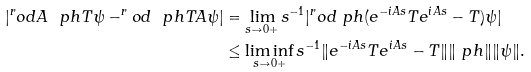Convert formula to latex. <formula><loc_0><loc_0><loc_500><loc_500>| ^ { r } o d { A \ p h } { T \psi } - ^ { r } o d { \ p h } { T A \psi } | & = \lim _ { s \to 0 + } s ^ { - 1 } | ^ { r } o d { \ p h } { ( e ^ { - i A s } T e ^ { i A s } - T ) \psi } | \\ & \leq \liminf _ { s \to 0 + } s ^ { - 1 } \| e ^ { - i A s } T e ^ { i A s } - T \| \| \ p h \| \| \psi \| .</formula> 